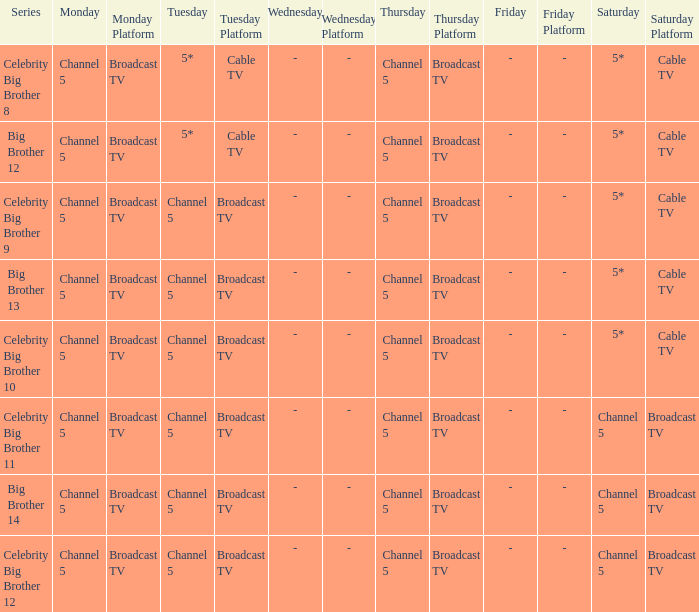Which Thursday does big brother 13 air? Channel 5. 